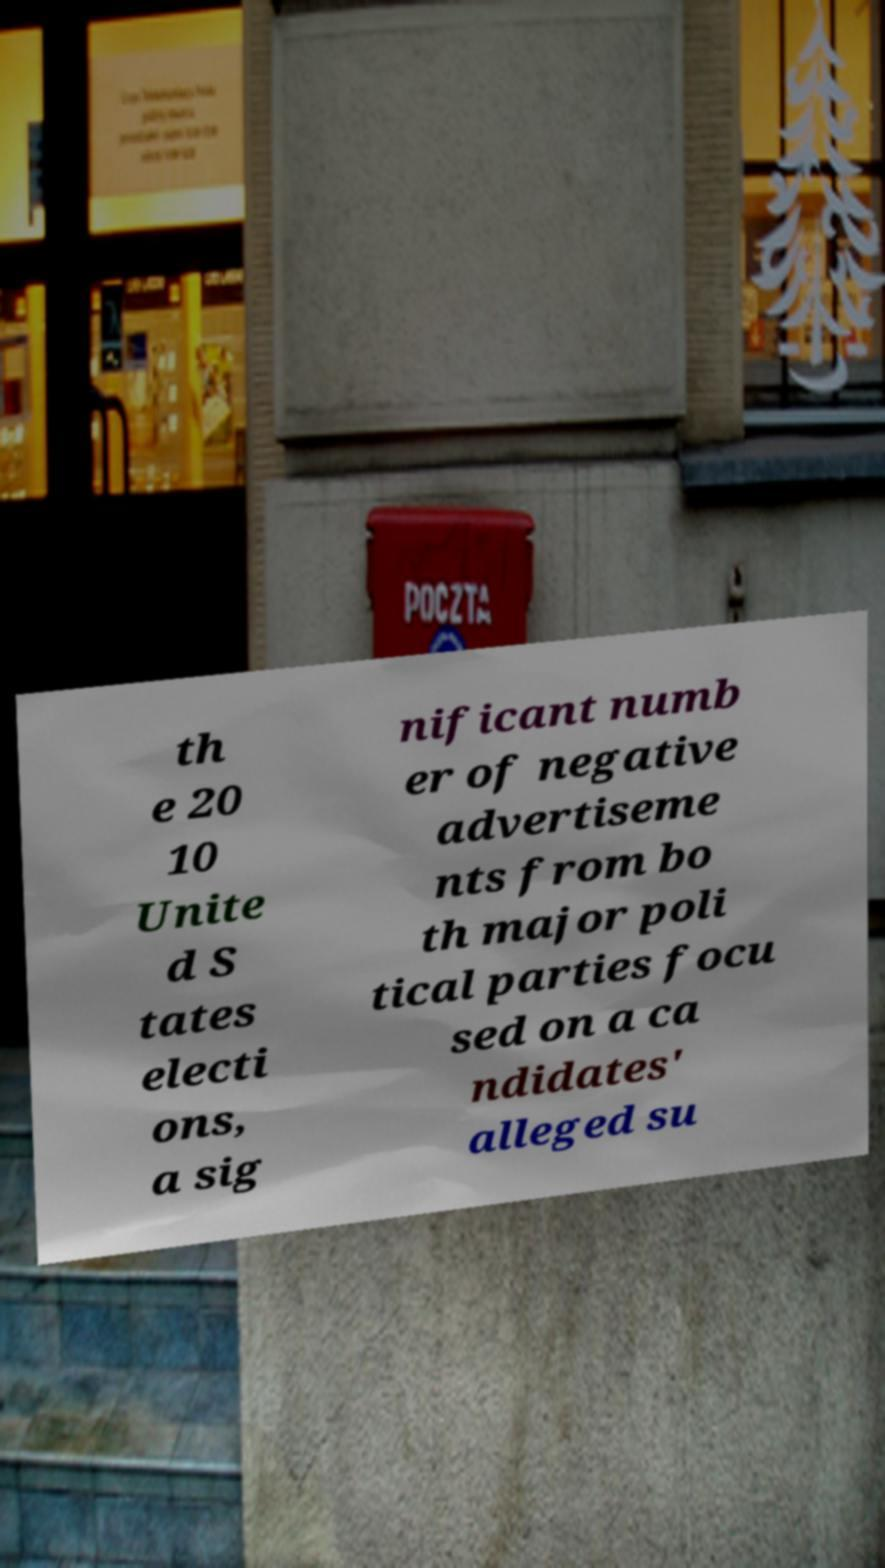There's text embedded in this image that I need extracted. Can you transcribe it verbatim? th e 20 10 Unite d S tates electi ons, a sig nificant numb er of negative advertiseme nts from bo th major poli tical parties focu sed on a ca ndidates' alleged su 